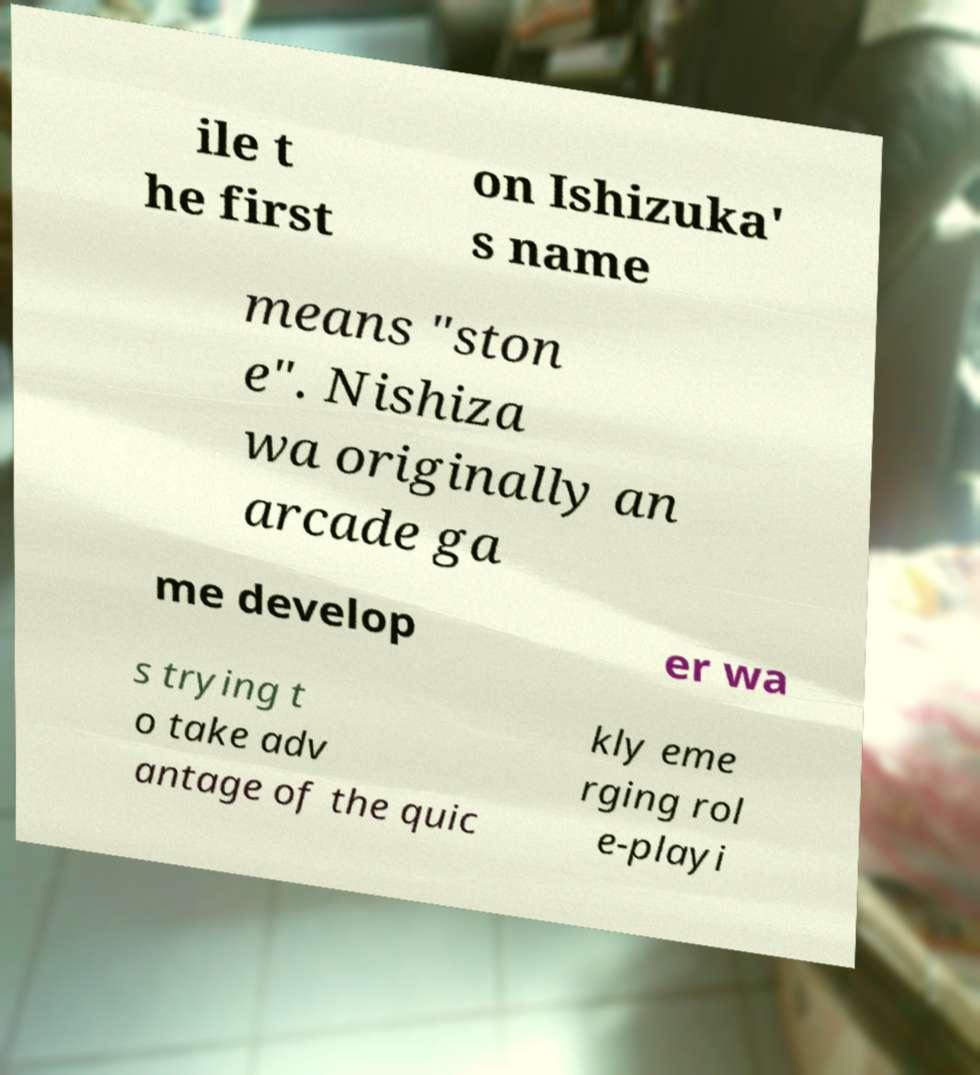Please identify and transcribe the text found in this image. ile t he first on Ishizuka' s name means "ston e". Nishiza wa originally an arcade ga me develop er wa s trying t o take adv antage of the quic kly eme rging rol e-playi 